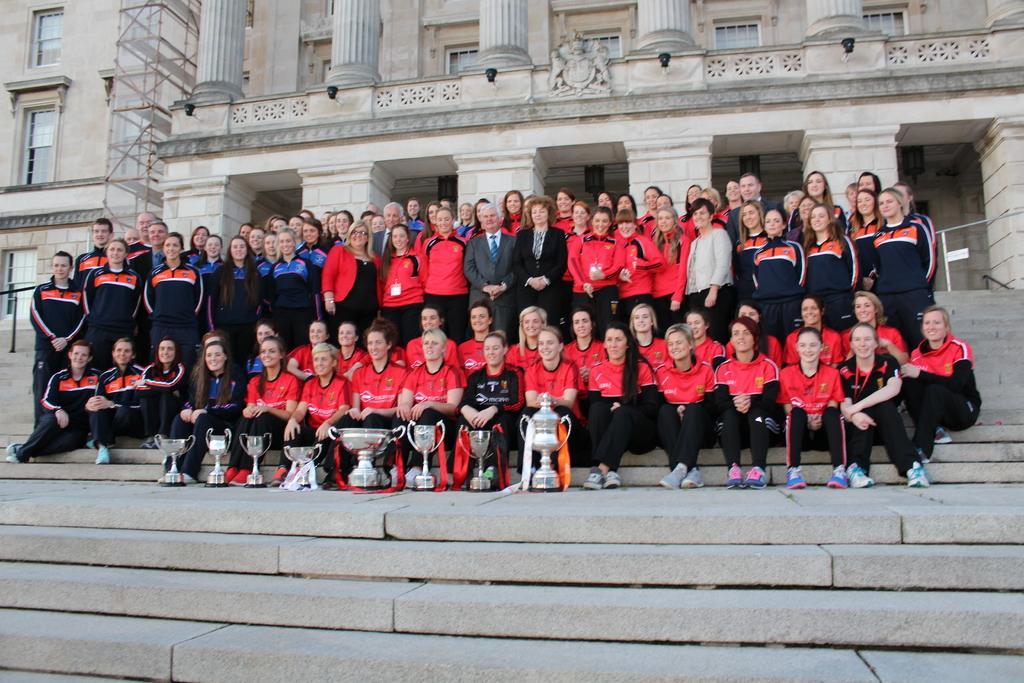Can you describe this image briefly? In this image I can see group of people some are sitting and some are standing, in front few people are wearing black and red color jersey and at the back few people are wearing black and blue color jersey. I can also see few shields, background I can see few buildings in cream color. 